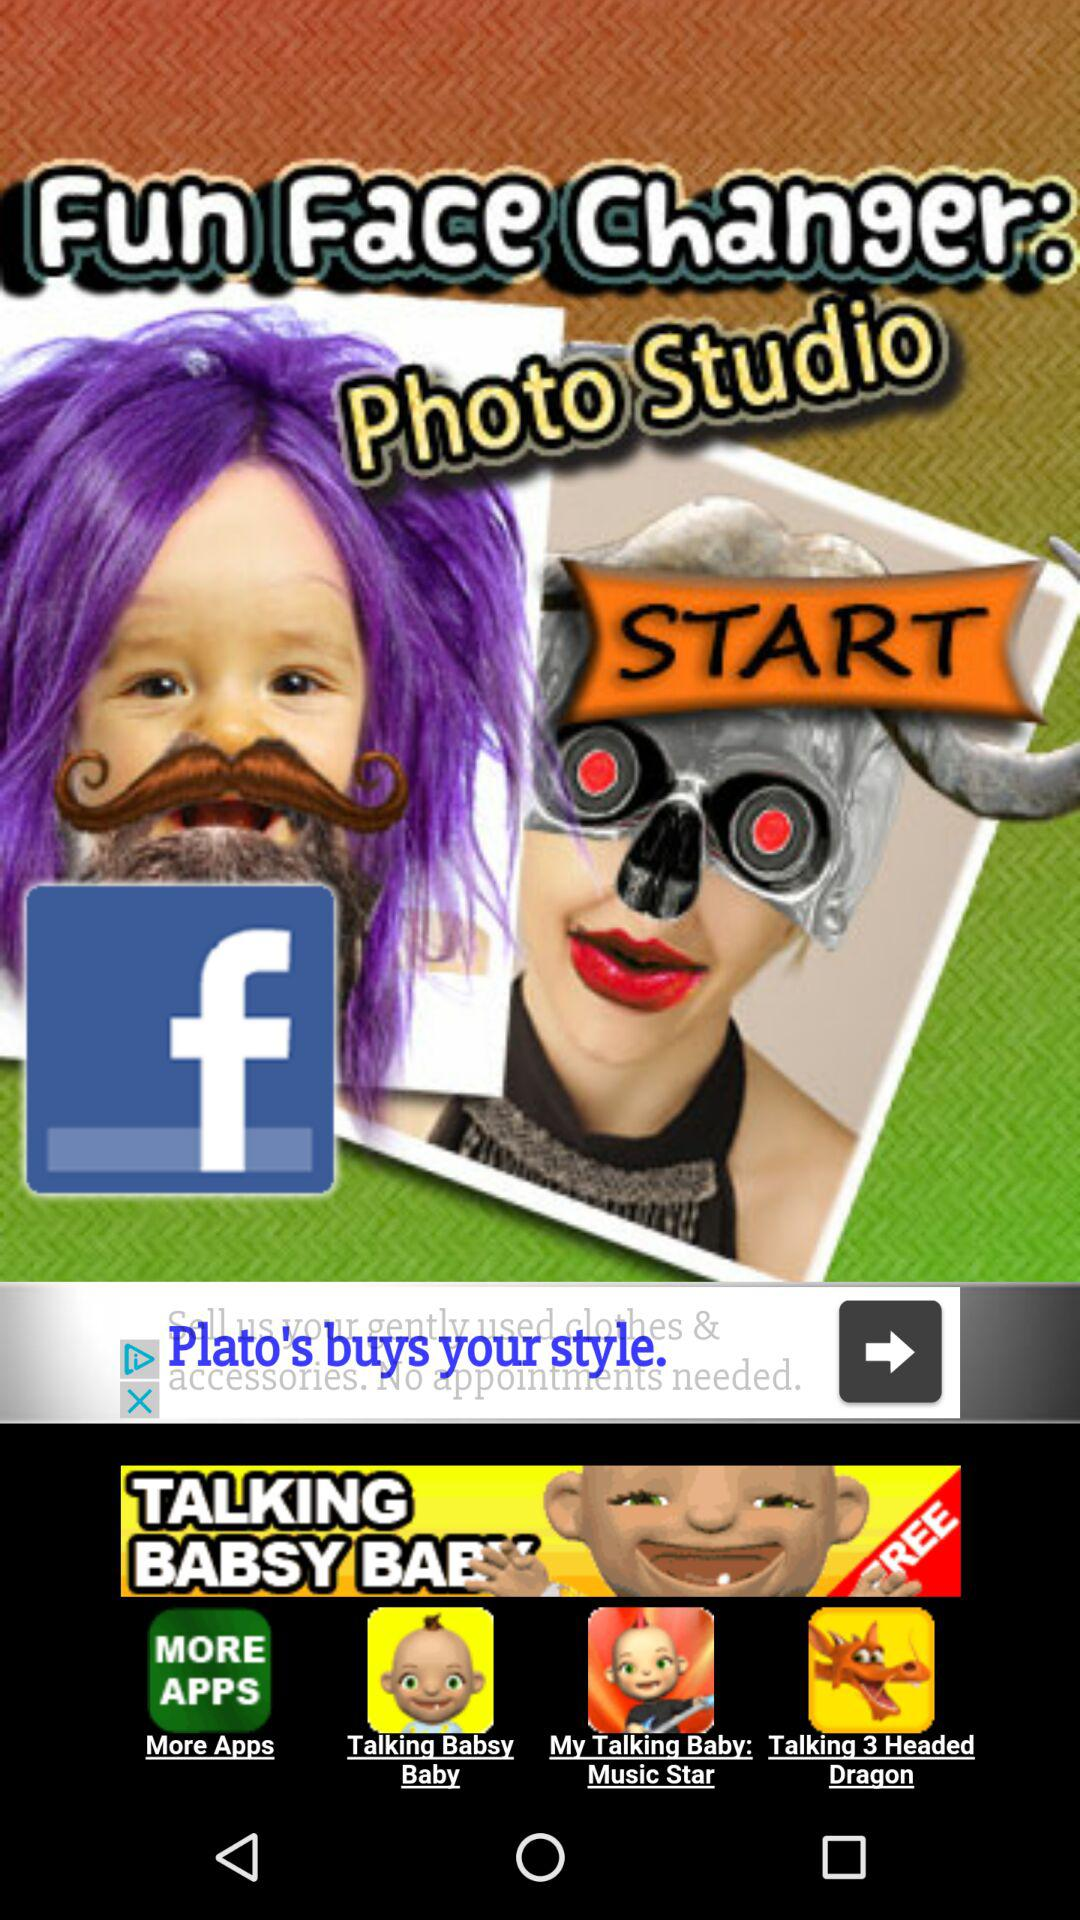What is the application name? The application name is "Fun Face Changer: Photo Studio". 